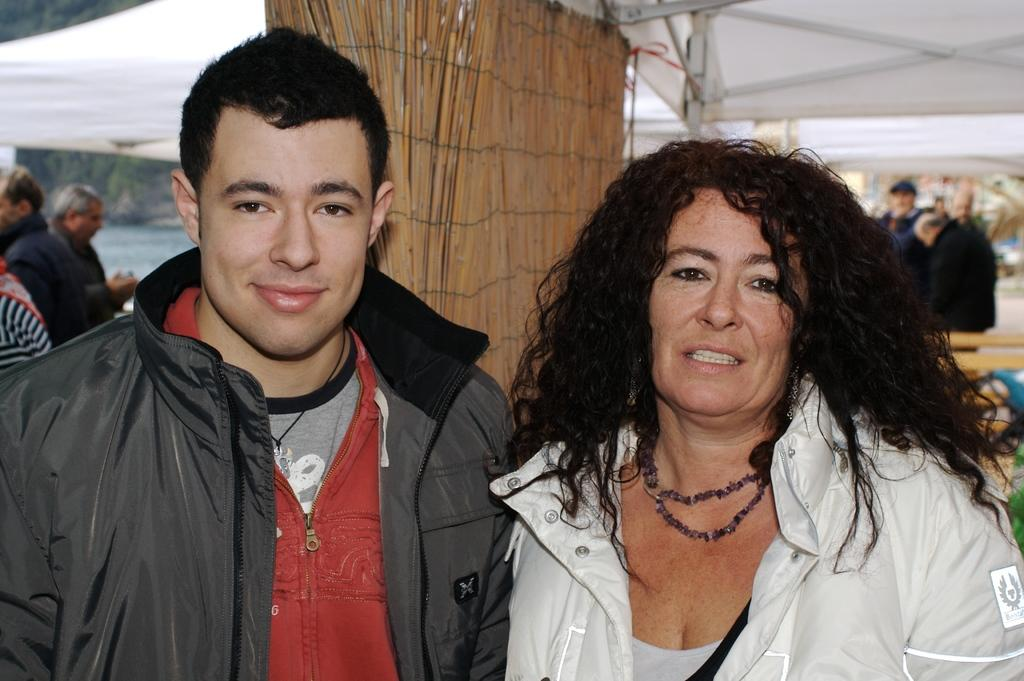What can be seen in the image? There is a couple in the image. How are the individuals in the couple feeling? Both individuals in the couple are smiling. Are there any other people visible in the image? Yes, there are people standing in the background of the image. What type of stick can be seen in the hands of the couple? There is no stick present in the image; the couple is not holding anything. How many flowers are visible in the image? There are no flowers present in the image. 